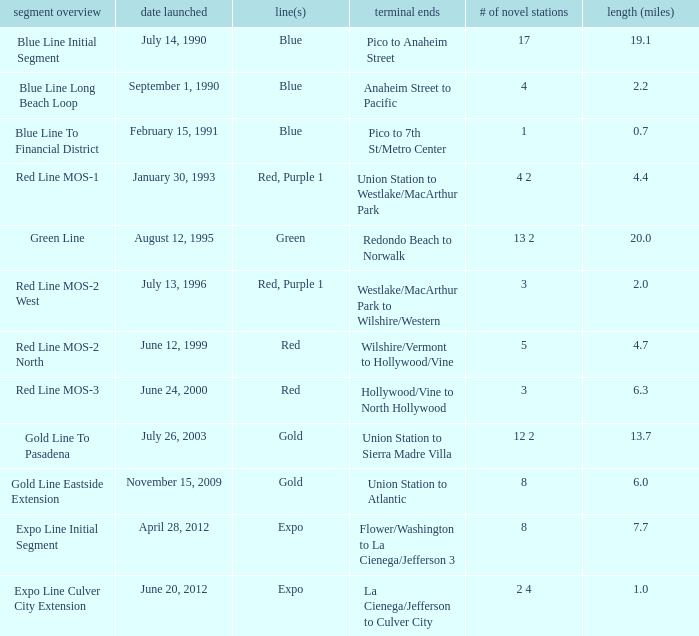What is the lenth (miles) of endpoints westlake/macarthur park to wilshire/western? 2.0. 